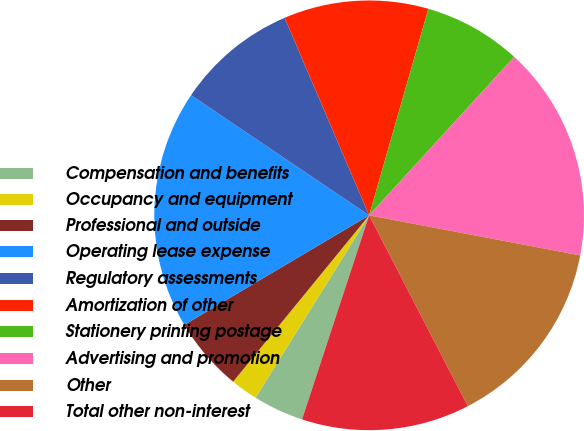<chart> <loc_0><loc_0><loc_500><loc_500><pie_chart><fcel>Compensation and benefits<fcel>Occupancy and equipment<fcel>Professional and outside<fcel>Operating lease expense<fcel>Regulatory assessments<fcel>Amortization of other<fcel>Stationery printing postage<fcel>Advertising and promotion<fcel>Other<fcel>Total other non-interest<nl><fcel>3.81%<fcel>2.04%<fcel>5.58%<fcel>17.96%<fcel>9.12%<fcel>10.88%<fcel>7.35%<fcel>16.19%<fcel>14.42%<fcel>12.65%<nl></chart> 